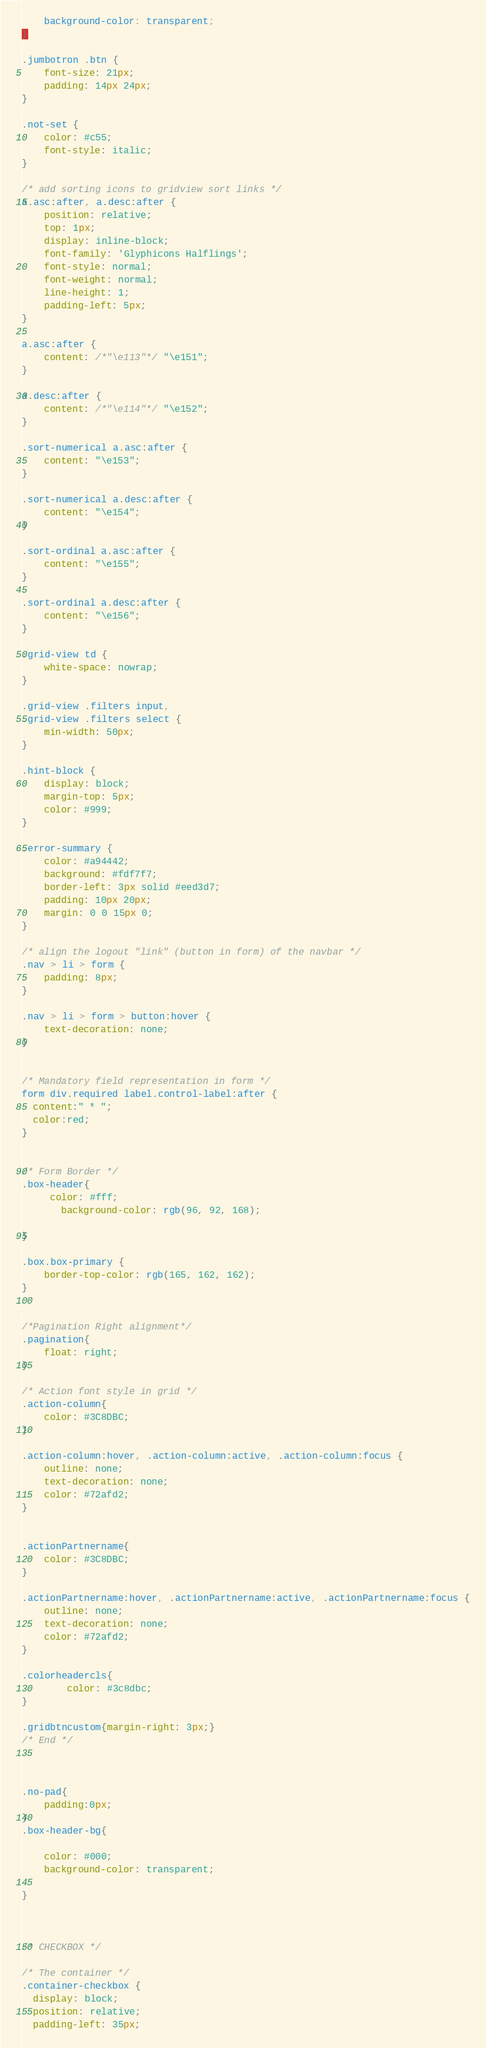Convert code to text. <code><loc_0><loc_0><loc_500><loc_500><_CSS_>    background-color: transparent;
}

.jumbotron .btn {
    font-size: 21px;
    padding: 14px 24px;
}

.not-set {
    color: #c55;
    font-style: italic;
}

/* add sorting icons to gridview sort links */
a.asc:after, a.desc:after {
    position: relative;
    top: 1px;
    display: inline-block;
    font-family: 'Glyphicons Halflings';
    font-style: normal;
    font-weight: normal;
    line-height: 1;
    padding-left: 5px;
}

a.asc:after {
    content: /*"\e113"*/ "\e151";
}

a.desc:after {
    content: /*"\e114"*/ "\e152";
}

.sort-numerical a.asc:after {
    content: "\e153";
}

.sort-numerical a.desc:after {
    content: "\e154";
}

.sort-ordinal a.asc:after {
    content: "\e155";
}

.sort-ordinal a.desc:after {
    content: "\e156";
}

.grid-view td {
    white-space: nowrap;
}

.grid-view .filters input,
.grid-view .filters select {
    min-width: 50px;
}

.hint-block {
    display: block;
    margin-top: 5px;
    color: #999;
}

.error-summary {
    color: #a94442;
    background: #fdf7f7;
    border-left: 3px solid #eed3d7;
    padding: 10px 20px;
    margin: 0 0 15px 0;
}

/* align the logout "link" (button in form) of the navbar */
.nav > li > form {
    padding: 8px;
}

.nav > li > form > button:hover {
    text-decoration: none;
}


/* Mandatory field representation in form */
form div.required label.control-label:after {
  content:" * ";
  color:red;
}


/* Form Border */
.box-header{
     color: #fff;
       background-color: rgb(96, 92, 168);
   
}

.box.box-primary {
    border-top-color: rgb(165, 162, 162);
}


/*Pagination Right alignment*/
.pagination{
    float: right;
}

/* Action font style in grid */
.action-column{
    color: #3C8DBC;
}

.action-column:hover, .action-column:active, .action-column:focus {
    outline: none;
    text-decoration: none;
    color: #72afd2;
}


.actionPartnername{
    color: #3C8DBC;
}

.actionPartnername:hover, .actionPartnername:active, .actionPartnername:focus {
    outline: none;
    text-decoration: none;
    color: #72afd2;
}

.colorheadercls{
        color: #3c8dbc;
}

.gridbtncustom{margin-right: 3px;}
/* End */



.no-pad{
	padding:0px;
}
.box-header-bg{
 
    color: #000;
    background-color: transparent;
 
}



/* CHECKBOX */

/* The container */
.container-checkbox {
  display: block;
  position: relative;
  padding-left: 35px;</code> 